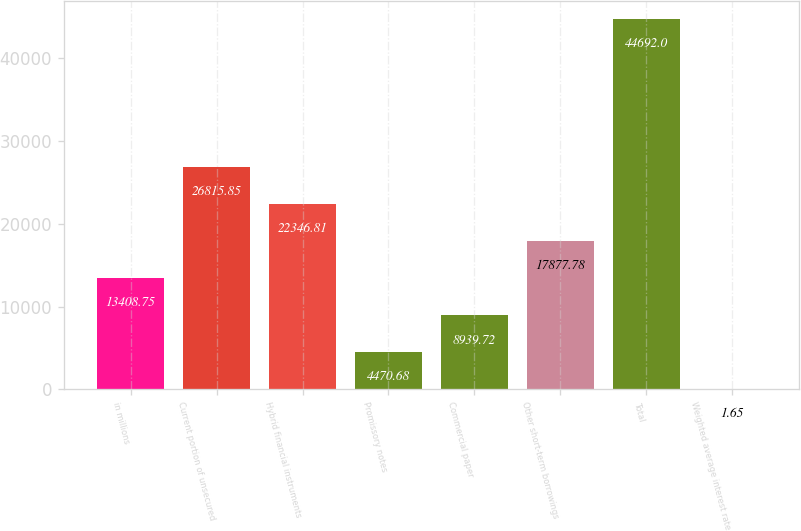<chart> <loc_0><loc_0><loc_500><loc_500><bar_chart><fcel>in millions<fcel>Current portion of unsecured<fcel>Hybrid financial instruments<fcel>Promissory notes<fcel>Commercial paper<fcel>Other short-term borrowings<fcel>Total<fcel>Weighted average interest rate<nl><fcel>13408.8<fcel>26815.8<fcel>22346.8<fcel>4470.68<fcel>8939.72<fcel>17877.8<fcel>44692<fcel>1.65<nl></chart> 